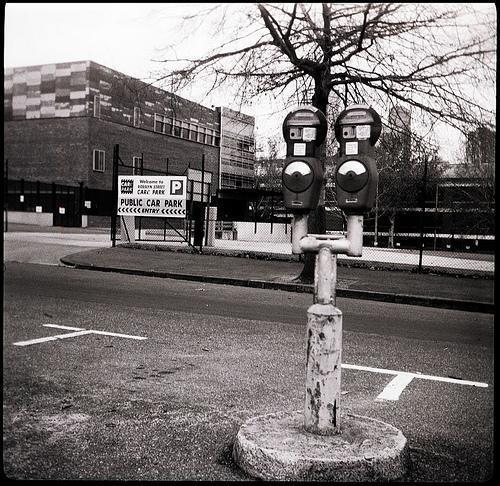How many parking meters are there?
Give a very brief answer. 2. How many parking meters are in the photo?
Give a very brief answer. 2. 